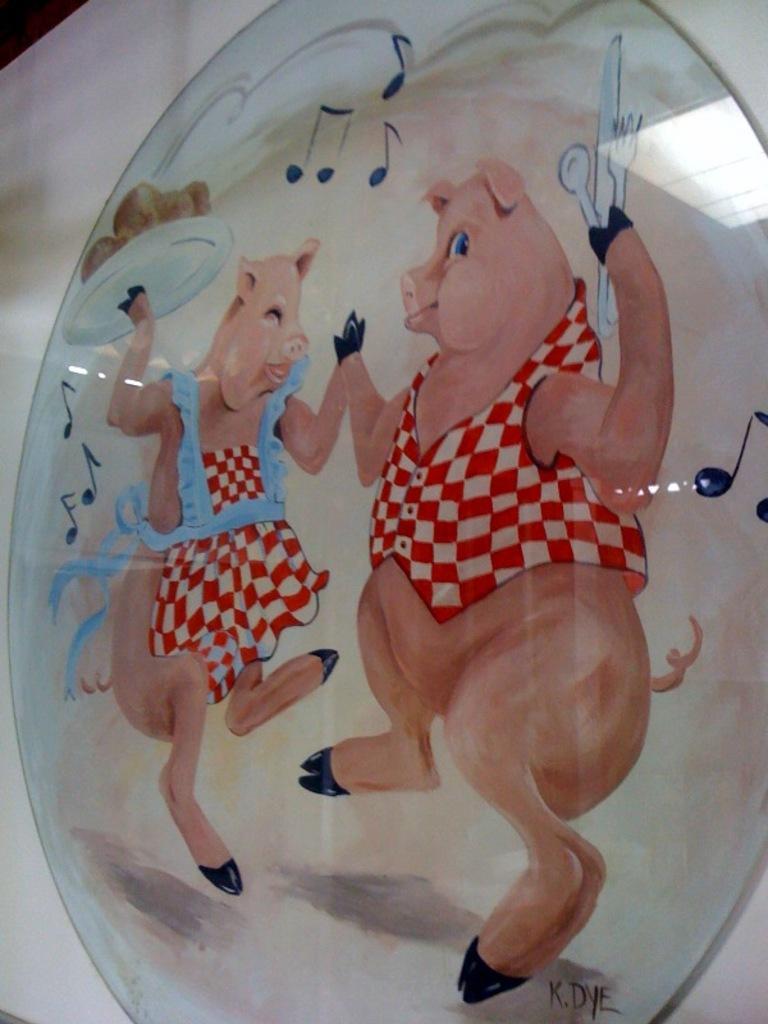In one or two sentences, can you explain what this image depicts? In this image we can see a picture. In the picture there are two pigs. Of them one is carrying a serving plate in the hand and the other is holding cutlery in the hand. 